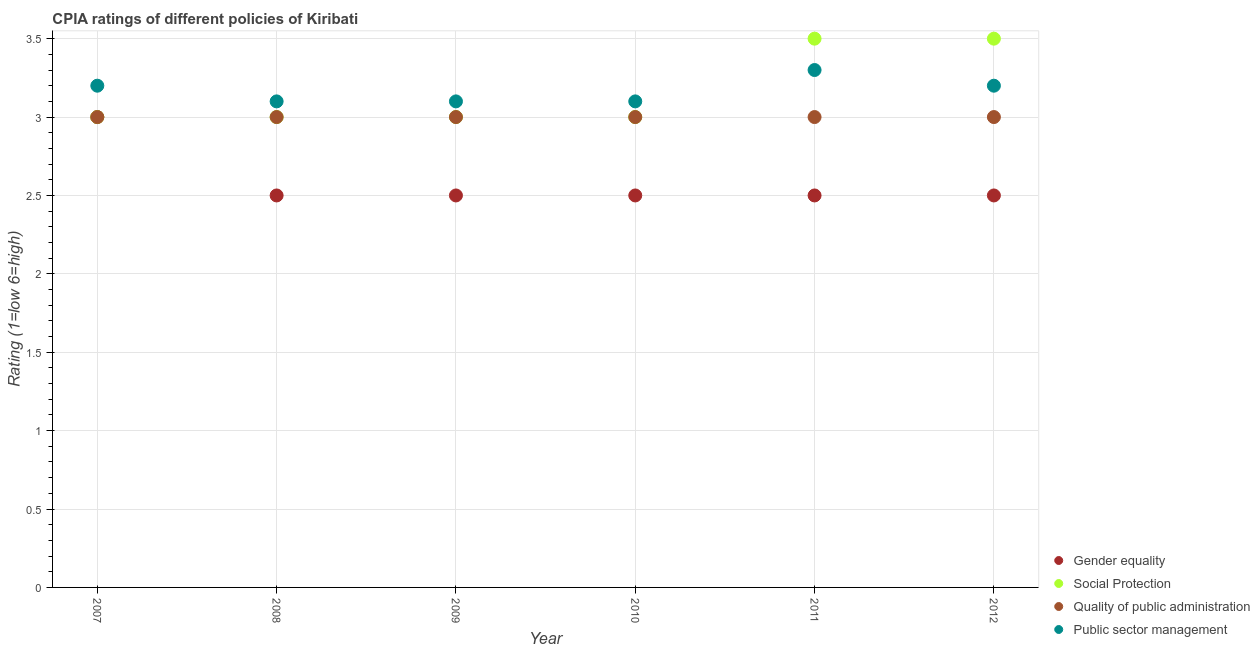How many different coloured dotlines are there?
Make the answer very short. 4. What is the cpia rating of social protection in 2010?
Give a very brief answer. 3. Across all years, what is the minimum cpia rating of quality of public administration?
Offer a very short reply. 3. In which year was the cpia rating of social protection maximum?
Your answer should be compact. 2011. In which year was the cpia rating of social protection minimum?
Your answer should be very brief. 2007. What is the difference between the cpia rating of gender equality in 2007 and the cpia rating of quality of public administration in 2012?
Ensure brevity in your answer.  0. What is the average cpia rating of public sector management per year?
Your answer should be very brief. 3.17. In the year 2012, what is the difference between the cpia rating of public sector management and cpia rating of social protection?
Make the answer very short. -0.3. In how many years, is the cpia rating of quality of public administration greater than 0.2?
Keep it short and to the point. 6. What is the ratio of the cpia rating of social protection in 2007 to that in 2008?
Ensure brevity in your answer.  1. Is the difference between the cpia rating of social protection in 2008 and 2012 greater than the difference between the cpia rating of gender equality in 2008 and 2012?
Provide a short and direct response. No. Is the sum of the cpia rating of social protection in 2008 and 2012 greater than the maximum cpia rating of quality of public administration across all years?
Your answer should be very brief. Yes. Is it the case that in every year, the sum of the cpia rating of gender equality and cpia rating of social protection is greater than the sum of cpia rating of quality of public administration and cpia rating of public sector management?
Offer a very short reply. Yes. Is it the case that in every year, the sum of the cpia rating of gender equality and cpia rating of social protection is greater than the cpia rating of quality of public administration?
Your response must be concise. Yes. Does the cpia rating of public sector management monotonically increase over the years?
Ensure brevity in your answer.  No. Is the cpia rating of public sector management strictly greater than the cpia rating of gender equality over the years?
Keep it short and to the point. Yes. Is the cpia rating of gender equality strictly less than the cpia rating of public sector management over the years?
Provide a short and direct response. Yes. How many years are there in the graph?
Keep it short and to the point. 6. Does the graph contain grids?
Your response must be concise. Yes. Where does the legend appear in the graph?
Offer a terse response. Bottom right. What is the title of the graph?
Keep it short and to the point. CPIA ratings of different policies of Kiribati. Does "Efficiency of custom clearance process" appear as one of the legend labels in the graph?
Your response must be concise. No. What is the label or title of the Y-axis?
Make the answer very short. Rating (1=low 6=high). What is the Rating (1=low 6=high) in Social Protection in 2007?
Ensure brevity in your answer.  3. What is the Rating (1=low 6=high) in Gender equality in 2008?
Your answer should be very brief. 2.5. What is the Rating (1=low 6=high) of Social Protection in 2008?
Ensure brevity in your answer.  3. What is the Rating (1=low 6=high) in Quality of public administration in 2008?
Your answer should be very brief. 3. What is the Rating (1=low 6=high) of Public sector management in 2008?
Keep it short and to the point. 3.1. What is the Rating (1=low 6=high) in Gender equality in 2009?
Provide a succinct answer. 2.5. What is the Rating (1=low 6=high) of Gender equality in 2010?
Offer a terse response. 2.5. What is the Rating (1=low 6=high) in Quality of public administration in 2010?
Your answer should be very brief. 3. What is the Rating (1=low 6=high) of Gender equality in 2011?
Offer a very short reply. 2.5. What is the Rating (1=low 6=high) in Social Protection in 2011?
Keep it short and to the point. 3.5. What is the Rating (1=low 6=high) of Quality of public administration in 2011?
Your response must be concise. 3. What is the Rating (1=low 6=high) of Public sector management in 2011?
Provide a succinct answer. 3.3. Across all years, what is the maximum Rating (1=low 6=high) in Public sector management?
Offer a terse response. 3.3. Across all years, what is the minimum Rating (1=low 6=high) of Gender equality?
Give a very brief answer. 2.5. Across all years, what is the minimum Rating (1=low 6=high) in Social Protection?
Offer a terse response. 3. What is the total Rating (1=low 6=high) in Gender equality in the graph?
Your response must be concise. 15.5. What is the total Rating (1=low 6=high) in Social Protection in the graph?
Make the answer very short. 19. What is the total Rating (1=low 6=high) in Quality of public administration in the graph?
Offer a terse response. 18. What is the total Rating (1=low 6=high) in Public sector management in the graph?
Offer a terse response. 19. What is the difference between the Rating (1=low 6=high) in Quality of public administration in 2007 and that in 2008?
Provide a short and direct response. 0. What is the difference between the Rating (1=low 6=high) in Gender equality in 2007 and that in 2009?
Give a very brief answer. 0.5. What is the difference between the Rating (1=low 6=high) of Quality of public administration in 2007 and that in 2009?
Provide a short and direct response. 0. What is the difference between the Rating (1=low 6=high) of Public sector management in 2007 and that in 2009?
Your response must be concise. 0.1. What is the difference between the Rating (1=low 6=high) in Gender equality in 2007 and that in 2010?
Offer a terse response. 0.5. What is the difference between the Rating (1=low 6=high) in Social Protection in 2007 and that in 2010?
Provide a short and direct response. 0. What is the difference between the Rating (1=low 6=high) of Quality of public administration in 2007 and that in 2010?
Your answer should be very brief. 0. What is the difference between the Rating (1=low 6=high) in Quality of public administration in 2007 and that in 2011?
Give a very brief answer. 0. What is the difference between the Rating (1=low 6=high) of Public sector management in 2007 and that in 2011?
Make the answer very short. -0.1. What is the difference between the Rating (1=low 6=high) of Public sector management in 2007 and that in 2012?
Offer a terse response. 0. What is the difference between the Rating (1=low 6=high) in Gender equality in 2008 and that in 2009?
Your answer should be compact. 0. What is the difference between the Rating (1=low 6=high) in Quality of public administration in 2008 and that in 2009?
Keep it short and to the point. 0. What is the difference between the Rating (1=low 6=high) of Quality of public administration in 2008 and that in 2010?
Give a very brief answer. 0. What is the difference between the Rating (1=low 6=high) in Gender equality in 2008 and that in 2011?
Offer a very short reply. 0. What is the difference between the Rating (1=low 6=high) of Social Protection in 2008 and that in 2011?
Provide a succinct answer. -0.5. What is the difference between the Rating (1=low 6=high) of Quality of public administration in 2008 and that in 2011?
Your answer should be compact. 0. What is the difference between the Rating (1=low 6=high) of Gender equality in 2008 and that in 2012?
Keep it short and to the point. 0. What is the difference between the Rating (1=low 6=high) in Quality of public administration in 2008 and that in 2012?
Offer a terse response. 0. What is the difference between the Rating (1=low 6=high) in Public sector management in 2008 and that in 2012?
Provide a succinct answer. -0.1. What is the difference between the Rating (1=low 6=high) in Quality of public administration in 2009 and that in 2010?
Your answer should be very brief. 0. What is the difference between the Rating (1=low 6=high) of Social Protection in 2009 and that in 2011?
Keep it short and to the point. -0.5. What is the difference between the Rating (1=low 6=high) in Quality of public administration in 2009 and that in 2011?
Offer a very short reply. 0. What is the difference between the Rating (1=low 6=high) of Social Protection in 2009 and that in 2012?
Keep it short and to the point. -0.5. What is the difference between the Rating (1=low 6=high) of Public sector management in 2009 and that in 2012?
Offer a terse response. -0.1. What is the difference between the Rating (1=low 6=high) in Social Protection in 2010 and that in 2012?
Provide a short and direct response. -0.5. What is the difference between the Rating (1=low 6=high) in Public sector management in 2010 and that in 2012?
Your answer should be compact. -0.1. What is the difference between the Rating (1=low 6=high) of Gender equality in 2011 and that in 2012?
Your answer should be very brief. 0. What is the difference between the Rating (1=low 6=high) of Public sector management in 2011 and that in 2012?
Your answer should be compact. 0.1. What is the difference between the Rating (1=low 6=high) in Gender equality in 2007 and the Rating (1=low 6=high) in Quality of public administration in 2008?
Your answer should be compact. 0. What is the difference between the Rating (1=low 6=high) of Gender equality in 2007 and the Rating (1=low 6=high) of Public sector management in 2008?
Your response must be concise. -0.1. What is the difference between the Rating (1=low 6=high) of Social Protection in 2007 and the Rating (1=low 6=high) of Public sector management in 2008?
Give a very brief answer. -0.1. What is the difference between the Rating (1=low 6=high) in Gender equality in 2007 and the Rating (1=low 6=high) in Quality of public administration in 2009?
Provide a short and direct response. 0. What is the difference between the Rating (1=low 6=high) of Gender equality in 2007 and the Rating (1=low 6=high) of Public sector management in 2009?
Offer a terse response. -0.1. What is the difference between the Rating (1=low 6=high) in Social Protection in 2007 and the Rating (1=low 6=high) in Public sector management in 2009?
Make the answer very short. -0.1. What is the difference between the Rating (1=low 6=high) of Quality of public administration in 2007 and the Rating (1=low 6=high) of Public sector management in 2009?
Keep it short and to the point. -0.1. What is the difference between the Rating (1=low 6=high) of Gender equality in 2007 and the Rating (1=low 6=high) of Social Protection in 2010?
Your answer should be compact. 0. What is the difference between the Rating (1=low 6=high) of Gender equality in 2007 and the Rating (1=low 6=high) of Quality of public administration in 2010?
Your answer should be compact. 0. What is the difference between the Rating (1=low 6=high) of Gender equality in 2007 and the Rating (1=low 6=high) of Public sector management in 2010?
Make the answer very short. -0.1. What is the difference between the Rating (1=low 6=high) in Social Protection in 2007 and the Rating (1=low 6=high) in Public sector management in 2010?
Make the answer very short. -0.1. What is the difference between the Rating (1=low 6=high) of Quality of public administration in 2007 and the Rating (1=low 6=high) of Public sector management in 2010?
Provide a succinct answer. -0.1. What is the difference between the Rating (1=low 6=high) of Gender equality in 2007 and the Rating (1=low 6=high) of Social Protection in 2011?
Offer a very short reply. -0.5. What is the difference between the Rating (1=low 6=high) of Social Protection in 2007 and the Rating (1=low 6=high) of Quality of public administration in 2011?
Offer a very short reply. 0. What is the difference between the Rating (1=low 6=high) of Quality of public administration in 2007 and the Rating (1=low 6=high) of Public sector management in 2011?
Ensure brevity in your answer.  -0.3. What is the difference between the Rating (1=low 6=high) of Gender equality in 2007 and the Rating (1=low 6=high) of Social Protection in 2012?
Your answer should be compact. -0.5. What is the difference between the Rating (1=low 6=high) of Gender equality in 2007 and the Rating (1=low 6=high) of Public sector management in 2012?
Your answer should be compact. -0.2. What is the difference between the Rating (1=low 6=high) in Social Protection in 2007 and the Rating (1=low 6=high) in Quality of public administration in 2012?
Give a very brief answer. 0. What is the difference between the Rating (1=low 6=high) of Social Protection in 2007 and the Rating (1=low 6=high) of Public sector management in 2012?
Your answer should be very brief. -0.2. What is the difference between the Rating (1=low 6=high) of Gender equality in 2008 and the Rating (1=low 6=high) of Social Protection in 2009?
Your answer should be compact. -0.5. What is the difference between the Rating (1=low 6=high) in Gender equality in 2008 and the Rating (1=low 6=high) in Public sector management in 2009?
Provide a short and direct response. -0.6. What is the difference between the Rating (1=low 6=high) of Social Protection in 2008 and the Rating (1=low 6=high) of Quality of public administration in 2009?
Offer a terse response. 0. What is the difference between the Rating (1=low 6=high) of Social Protection in 2008 and the Rating (1=low 6=high) of Public sector management in 2009?
Your response must be concise. -0.1. What is the difference between the Rating (1=low 6=high) of Gender equality in 2008 and the Rating (1=low 6=high) of Quality of public administration in 2010?
Offer a very short reply. -0.5. What is the difference between the Rating (1=low 6=high) of Gender equality in 2008 and the Rating (1=low 6=high) of Public sector management in 2010?
Your response must be concise. -0.6. What is the difference between the Rating (1=low 6=high) of Social Protection in 2008 and the Rating (1=low 6=high) of Public sector management in 2010?
Provide a short and direct response. -0.1. What is the difference between the Rating (1=low 6=high) in Gender equality in 2008 and the Rating (1=low 6=high) in Quality of public administration in 2011?
Make the answer very short. -0.5. What is the difference between the Rating (1=low 6=high) of Gender equality in 2008 and the Rating (1=low 6=high) of Public sector management in 2011?
Your response must be concise. -0.8. What is the difference between the Rating (1=low 6=high) of Social Protection in 2008 and the Rating (1=low 6=high) of Public sector management in 2011?
Keep it short and to the point. -0.3. What is the difference between the Rating (1=low 6=high) in Gender equality in 2008 and the Rating (1=low 6=high) in Social Protection in 2012?
Provide a succinct answer. -1. What is the difference between the Rating (1=low 6=high) in Gender equality in 2008 and the Rating (1=low 6=high) in Quality of public administration in 2012?
Offer a terse response. -0.5. What is the difference between the Rating (1=low 6=high) of Gender equality in 2008 and the Rating (1=low 6=high) of Public sector management in 2012?
Give a very brief answer. -0.7. What is the difference between the Rating (1=low 6=high) in Social Protection in 2008 and the Rating (1=low 6=high) in Quality of public administration in 2012?
Ensure brevity in your answer.  0. What is the difference between the Rating (1=low 6=high) of Social Protection in 2008 and the Rating (1=low 6=high) of Public sector management in 2012?
Provide a succinct answer. -0.2. What is the difference between the Rating (1=low 6=high) in Quality of public administration in 2008 and the Rating (1=low 6=high) in Public sector management in 2012?
Provide a succinct answer. -0.2. What is the difference between the Rating (1=low 6=high) in Gender equality in 2009 and the Rating (1=low 6=high) in Quality of public administration in 2010?
Your answer should be compact. -0.5. What is the difference between the Rating (1=low 6=high) of Social Protection in 2009 and the Rating (1=low 6=high) of Quality of public administration in 2010?
Make the answer very short. 0. What is the difference between the Rating (1=low 6=high) in Gender equality in 2009 and the Rating (1=low 6=high) in Social Protection in 2011?
Provide a succinct answer. -1. What is the difference between the Rating (1=low 6=high) in Gender equality in 2009 and the Rating (1=low 6=high) in Public sector management in 2011?
Make the answer very short. -0.8. What is the difference between the Rating (1=low 6=high) in Social Protection in 2009 and the Rating (1=low 6=high) in Quality of public administration in 2011?
Keep it short and to the point. 0. What is the difference between the Rating (1=low 6=high) of Social Protection in 2009 and the Rating (1=low 6=high) of Public sector management in 2011?
Provide a succinct answer. -0.3. What is the difference between the Rating (1=low 6=high) of Gender equality in 2009 and the Rating (1=low 6=high) of Social Protection in 2012?
Offer a very short reply. -1. What is the difference between the Rating (1=low 6=high) of Gender equality in 2009 and the Rating (1=low 6=high) of Public sector management in 2012?
Offer a terse response. -0.7. What is the difference between the Rating (1=low 6=high) in Social Protection in 2009 and the Rating (1=low 6=high) in Quality of public administration in 2012?
Your answer should be compact. 0. What is the difference between the Rating (1=low 6=high) of Gender equality in 2010 and the Rating (1=low 6=high) of Social Protection in 2011?
Your answer should be compact. -1. What is the difference between the Rating (1=low 6=high) in Gender equality in 2010 and the Rating (1=low 6=high) in Quality of public administration in 2011?
Your answer should be very brief. -0.5. What is the difference between the Rating (1=low 6=high) in Gender equality in 2010 and the Rating (1=low 6=high) in Quality of public administration in 2012?
Give a very brief answer. -0.5. What is the difference between the Rating (1=low 6=high) of Gender equality in 2011 and the Rating (1=low 6=high) of Social Protection in 2012?
Your answer should be very brief. -1. What is the difference between the Rating (1=low 6=high) in Gender equality in 2011 and the Rating (1=low 6=high) in Quality of public administration in 2012?
Your answer should be compact. -0.5. What is the average Rating (1=low 6=high) in Gender equality per year?
Give a very brief answer. 2.58. What is the average Rating (1=low 6=high) in Social Protection per year?
Provide a short and direct response. 3.17. What is the average Rating (1=low 6=high) of Public sector management per year?
Make the answer very short. 3.17. In the year 2007, what is the difference between the Rating (1=low 6=high) of Gender equality and Rating (1=low 6=high) of Social Protection?
Provide a succinct answer. 0. In the year 2007, what is the difference between the Rating (1=low 6=high) in Gender equality and Rating (1=low 6=high) in Public sector management?
Offer a terse response. -0.2. In the year 2007, what is the difference between the Rating (1=low 6=high) of Social Protection and Rating (1=low 6=high) of Quality of public administration?
Your answer should be compact. 0. In the year 2007, what is the difference between the Rating (1=low 6=high) in Social Protection and Rating (1=low 6=high) in Public sector management?
Your response must be concise. -0.2. In the year 2007, what is the difference between the Rating (1=low 6=high) of Quality of public administration and Rating (1=low 6=high) of Public sector management?
Make the answer very short. -0.2. In the year 2008, what is the difference between the Rating (1=low 6=high) in Gender equality and Rating (1=low 6=high) in Social Protection?
Provide a succinct answer. -0.5. In the year 2008, what is the difference between the Rating (1=low 6=high) of Gender equality and Rating (1=low 6=high) of Quality of public administration?
Ensure brevity in your answer.  -0.5. In the year 2008, what is the difference between the Rating (1=low 6=high) of Social Protection and Rating (1=low 6=high) of Quality of public administration?
Provide a succinct answer. 0. In the year 2009, what is the difference between the Rating (1=low 6=high) in Gender equality and Rating (1=low 6=high) in Quality of public administration?
Provide a short and direct response. -0.5. In the year 2009, what is the difference between the Rating (1=low 6=high) of Social Protection and Rating (1=low 6=high) of Quality of public administration?
Ensure brevity in your answer.  0. In the year 2009, what is the difference between the Rating (1=low 6=high) in Social Protection and Rating (1=low 6=high) in Public sector management?
Your response must be concise. -0.1. In the year 2009, what is the difference between the Rating (1=low 6=high) in Quality of public administration and Rating (1=low 6=high) in Public sector management?
Offer a very short reply. -0.1. In the year 2010, what is the difference between the Rating (1=low 6=high) of Gender equality and Rating (1=low 6=high) of Social Protection?
Your answer should be compact. -0.5. In the year 2010, what is the difference between the Rating (1=low 6=high) of Gender equality and Rating (1=low 6=high) of Quality of public administration?
Your answer should be very brief. -0.5. In the year 2010, what is the difference between the Rating (1=low 6=high) of Gender equality and Rating (1=low 6=high) of Public sector management?
Your answer should be compact. -0.6. In the year 2010, what is the difference between the Rating (1=low 6=high) in Quality of public administration and Rating (1=low 6=high) in Public sector management?
Make the answer very short. -0.1. In the year 2011, what is the difference between the Rating (1=low 6=high) of Gender equality and Rating (1=low 6=high) of Social Protection?
Your response must be concise. -1. In the year 2011, what is the difference between the Rating (1=low 6=high) of Gender equality and Rating (1=low 6=high) of Quality of public administration?
Give a very brief answer. -0.5. In the year 2011, what is the difference between the Rating (1=low 6=high) in Social Protection and Rating (1=low 6=high) in Quality of public administration?
Your response must be concise. 0.5. In the year 2011, what is the difference between the Rating (1=low 6=high) of Quality of public administration and Rating (1=low 6=high) of Public sector management?
Offer a terse response. -0.3. In the year 2012, what is the difference between the Rating (1=low 6=high) of Gender equality and Rating (1=low 6=high) of Quality of public administration?
Ensure brevity in your answer.  -0.5. In the year 2012, what is the difference between the Rating (1=low 6=high) of Social Protection and Rating (1=low 6=high) of Quality of public administration?
Your answer should be very brief. 0.5. In the year 2012, what is the difference between the Rating (1=low 6=high) of Social Protection and Rating (1=low 6=high) of Public sector management?
Your response must be concise. 0.3. What is the ratio of the Rating (1=low 6=high) in Public sector management in 2007 to that in 2008?
Your answer should be compact. 1.03. What is the ratio of the Rating (1=low 6=high) in Social Protection in 2007 to that in 2009?
Make the answer very short. 1. What is the ratio of the Rating (1=low 6=high) of Quality of public administration in 2007 to that in 2009?
Offer a terse response. 1. What is the ratio of the Rating (1=low 6=high) in Public sector management in 2007 to that in 2009?
Your answer should be very brief. 1.03. What is the ratio of the Rating (1=low 6=high) of Public sector management in 2007 to that in 2010?
Provide a succinct answer. 1.03. What is the ratio of the Rating (1=low 6=high) of Gender equality in 2007 to that in 2011?
Your answer should be very brief. 1.2. What is the ratio of the Rating (1=low 6=high) of Quality of public administration in 2007 to that in 2011?
Give a very brief answer. 1. What is the ratio of the Rating (1=low 6=high) of Public sector management in 2007 to that in 2011?
Give a very brief answer. 0.97. What is the ratio of the Rating (1=low 6=high) in Public sector management in 2007 to that in 2012?
Provide a succinct answer. 1. What is the ratio of the Rating (1=low 6=high) of Gender equality in 2008 to that in 2009?
Your answer should be very brief. 1. What is the ratio of the Rating (1=low 6=high) in Social Protection in 2008 to that in 2009?
Your answer should be very brief. 1. What is the ratio of the Rating (1=low 6=high) of Public sector management in 2008 to that in 2009?
Make the answer very short. 1. What is the ratio of the Rating (1=low 6=high) in Gender equality in 2008 to that in 2011?
Your answer should be very brief. 1. What is the ratio of the Rating (1=low 6=high) in Social Protection in 2008 to that in 2011?
Your answer should be compact. 0.86. What is the ratio of the Rating (1=low 6=high) of Quality of public administration in 2008 to that in 2011?
Offer a very short reply. 1. What is the ratio of the Rating (1=low 6=high) in Public sector management in 2008 to that in 2011?
Your response must be concise. 0.94. What is the ratio of the Rating (1=low 6=high) of Gender equality in 2008 to that in 2012?
Your response must be concise. 1. What is the ratio of the Rating (1=low 6=high) of Social Protection in 2008 to that in 2012?
Your answer should be compact. 0.86. What is the ratio of the Rating (1=low 6=high) in Quality of public administration in 2008 to that in 2012?
Give a very brief answer. 1. What is the ratio of the Rating (1=low 6=high) in Public sector management in 2008 to that in 2012?
Ensure brevity in your answer.  0.97. What is the ratio of the Rating (1=low 6=high) of Gender equality in 2009 to that in 2010?
Keep it short and to the point. 1. What is the ratio of the Rating (1=low 6=high) in Social Protection in 2009 to that in 2010?
Your response must be concise. 1. What is the ratio of the Rating (1=low 6=high) of Quality of public administration in 2009 to that in 2010?
Your answer should be compact. 1. What is the ratio of the Rating (1=low 6=high) in Social Protection in 2009 to that in 2011?
Your answer should be very brief. 0.86. What is the ratio of the Rating (1=low 6=high) in Quality of public administration in 2009 to that in 2011?
Provide a succinct answer. 1. What is the ratio of the Rating (1=low 6=high) of Public sector management in 2009 to that in 2011?
Provide a short and direct response. 0.94. What is the ratio of the Rating (1=low 6=high) in Public sector management in 2009 to that in 2012?
Make the answer very short. 0.97. What is the ratio of the Rating (1=low 6=high) of Gender equality in 2010 to that in 2011?
Offer a terse response. 1. What is the ratio of the Rating (1=low 6=high) in Public sector management in 2010 to that in 2011?
Ensure brevity in your answer.  0.94. What is the ratio of the Rating (1=low 6=high) of Gender equality in 2010 to that in 2012?
Make the answer very short. 1. What is the ratio of the Rating (1=low 6=high) in Quality of public administration in 2010 to that in 2012?
Offer a terse response. 1. What is the ratio of the Rating (1=low 6=high) in Public sector management in 2010 to that in 2012?
Keep it short and to the point. 0.97. What is the ratio of the Rating (1=low 6=high) in Quality of public administration in 2011 to that in 2012?
Your answer should be very brief. 1. What is the ratio of the Rating (1=low 6=high) of Public sector management in 2011 to that in 2012?
Offer a terse response. 1.03. What is the difference between the highest and the lowest Rating (1=low 6=high) of Social Protection?
Give a very brief answer. 0.5. 